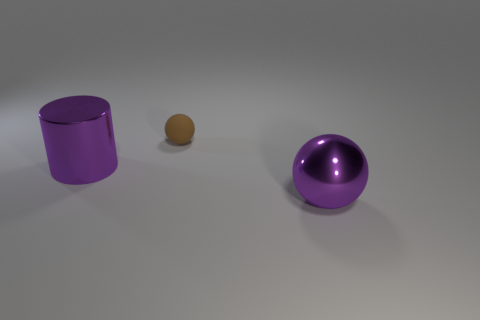Add 1 purple things. How many objects exist? 4 Subtract all balls. How many objects are left? 1 Subtract all big purple metallic cylinders. Subtract all tiny spheres. How many objects are left? 1 Add 2 big purple cylinders. How many big purple cylinders are left? 3 Add 2 large cylinders. How many large cylinders exist? 3 Subtract 0 yellow spheres. How many objects are left? 3 